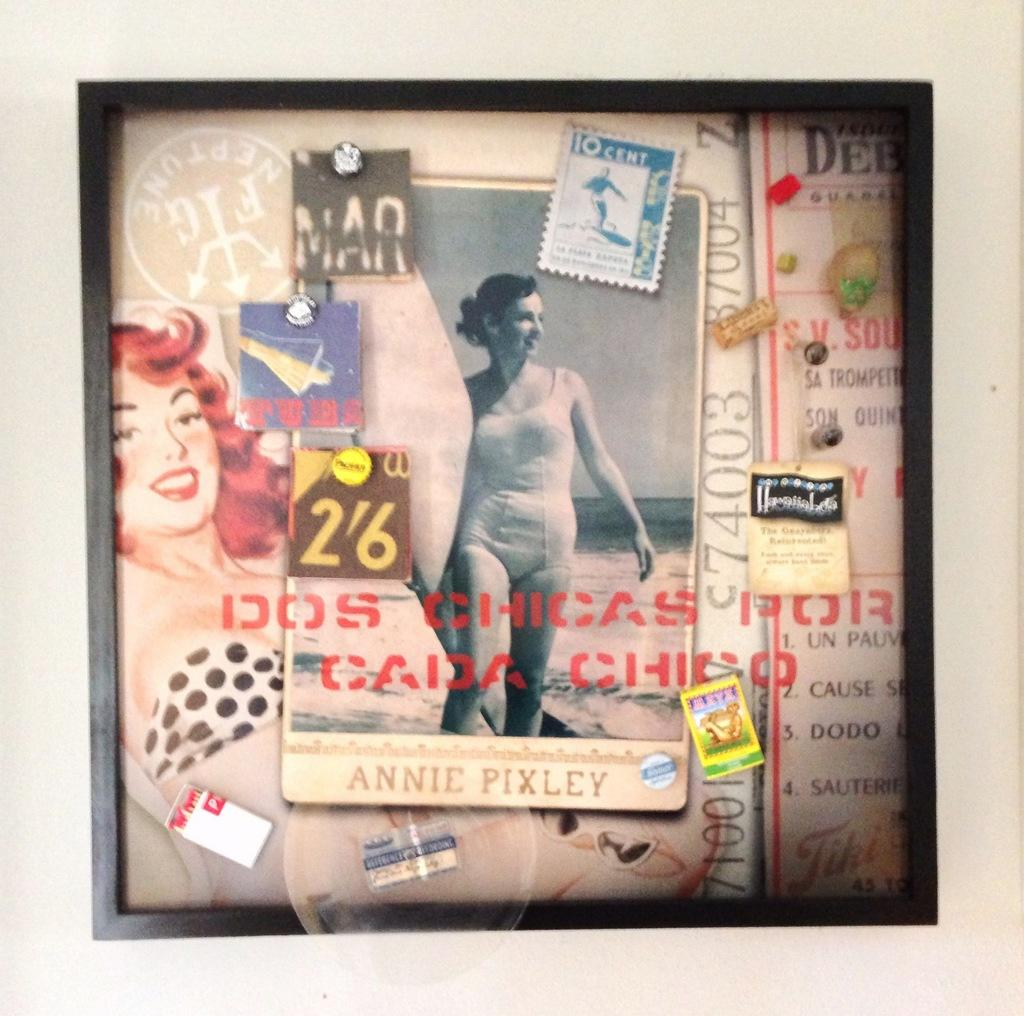What type of visual is the image? The image is a poster. What can be seen on the poster? There are photos on the poster. Are there any additional markings on the poster? Yes, there is a stamp and labels on the poster. What might be used to attach the poster to a surface? Pins are present on the poster for attaching it. What type of jam is being served on the shirt in the image? There is no shirt or jam present in the image; it is a poster with photos, a stamp, labels, and pins. How many eggs are visible on the poster? There are no eggs present on the poster. 